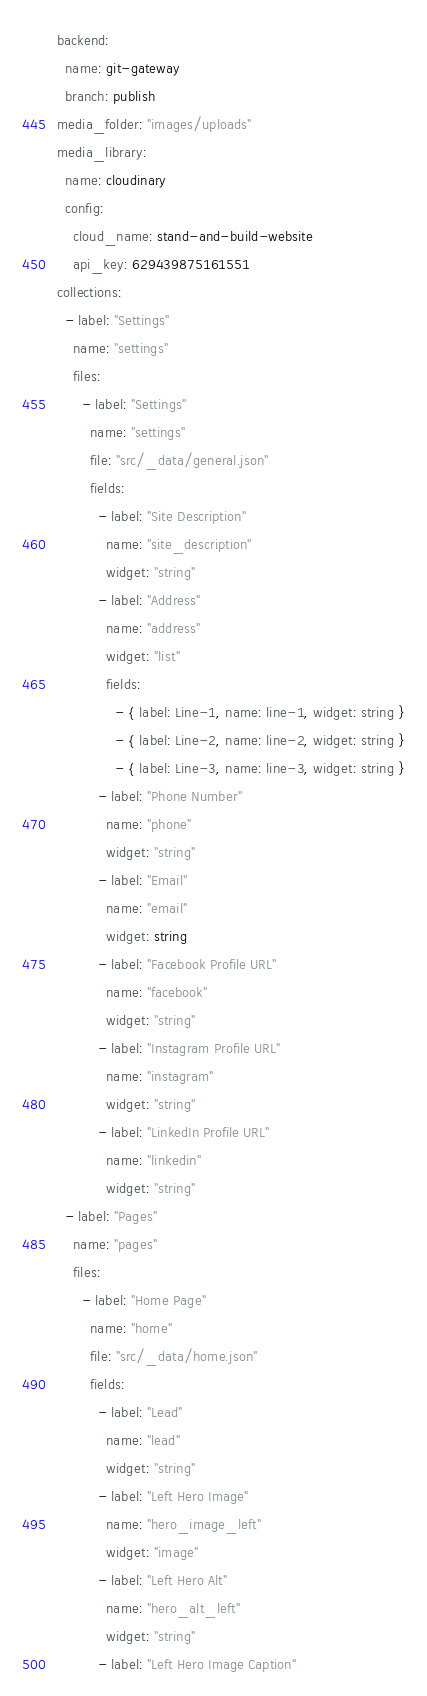Convert code to text. <code><loc_0><loc_0><loc_500><loc_500><_YAML_>backend:
  name: git-gateway
  branch: publish
media_folder: "images/uploads"
media_library:
  name: cloudinary
  config:
    cloud_name: stand-and-build-website
    api_key: 629439875161551
collections:
  - label: "Settings"
    name: "settings"
    files:
      - label: "Settings"
        name: "settings"
        file: "src/_data/general.json"
        fields:
          - label: "Site Description"
            name: "site_description"
            widget: "string"
          - label: "Address"
            name: "address"
            widget: "list"
            fields:
              - { label: Line-1, name: line-1, widget: string }
              - { label: Line-2, name: line-2, widget: string }
              - { label: Line-3, name: line-3, widget: string }
          - label: "Phone Number"
            name: "phone"
            widget: "string"
          - label: "Email"
            name: "email"
            widget: string
          - label: "Facebook Profile URL"
            name: "facebook"
            widget: "string"
          - label: "Instagram Profile URL"
            name: "instagram"
            widget: "string"
          - label: "LinkedIn Profile URL"
            name: "linkedin"
            widget: "string"
  - label: "Pages"
    name: "pages"
    files:
      - label: "Home Page"
        name: "home"
        file: "src/_data/home.json"
        fields:
          - label: "Lead"
            name: "lead"
            widget: "string"
          - label: "Left Hero Image"
            name: "hero_image_left"
            widget: "image"
          - label: "Left Hero Alt"
            name: "hero_alt_left"
            widget: "string"
          - label: "Left Hero Image Caption"</code> 